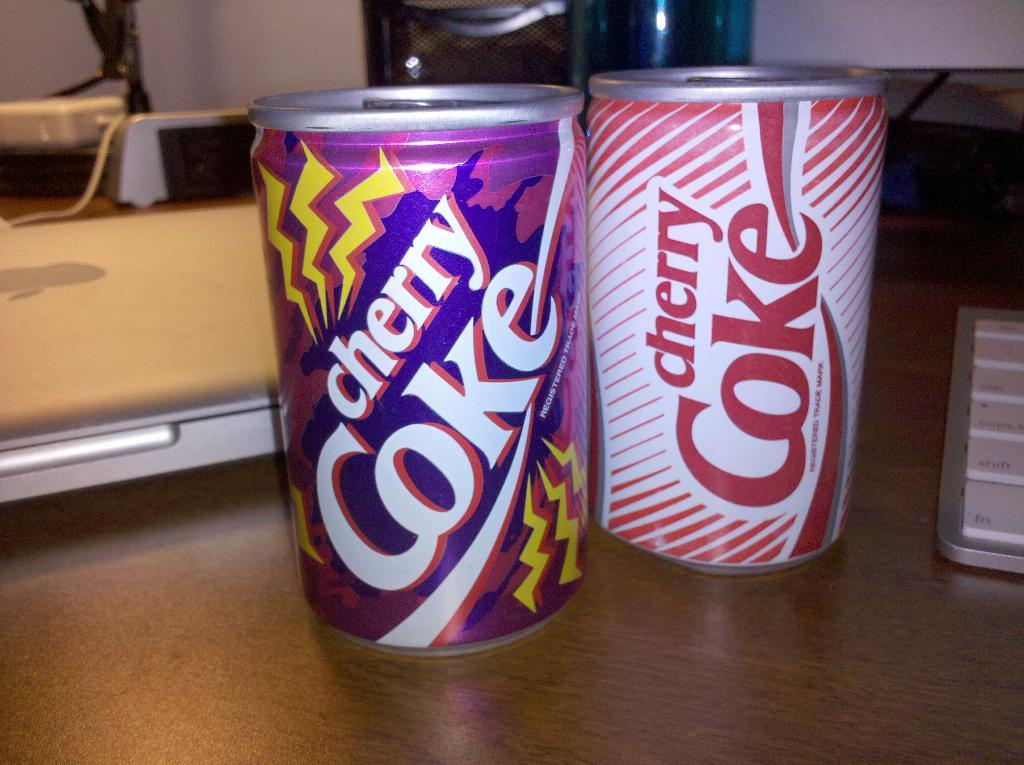<image>
Summarize the visual content of the image. a cherry coke that is on the table 